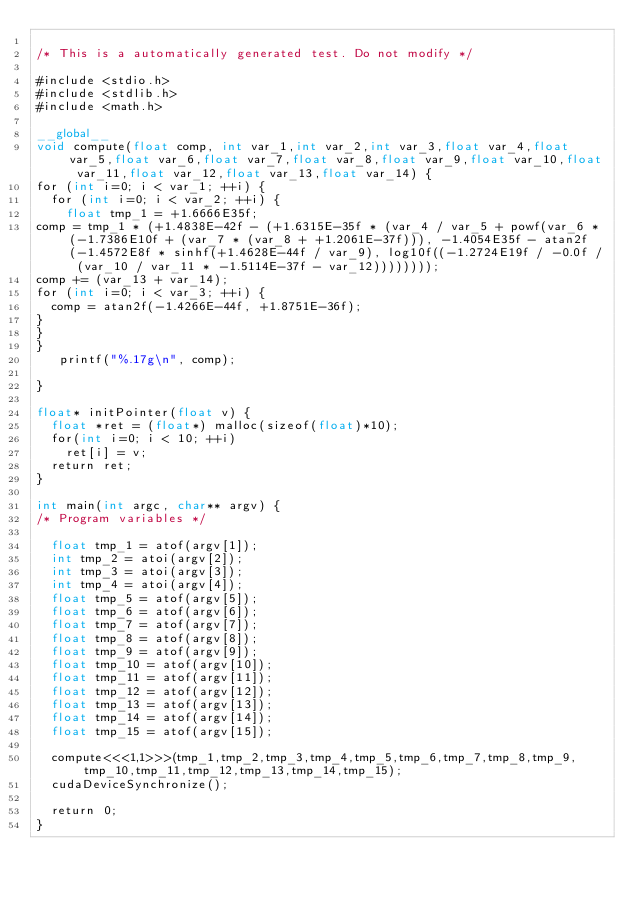<code> <loc_0><loc_0><loc_500><loc_500><_Cuda_>
/* This is a automatically generated test. Do not modify */

#include <stdio.h>
#include <stdlib.h>
#include <math.h>

__global__
void compute(float comp, int var_1,int var_2,int var_3,float var_4,float var_5,float var_6,float var_7,float var_8,float var_9,float var_10,float var_11,float var_12,float var_13,float var_14) {
for (int i=0; i < var_1; ++i) {
  for (int i=0; i < var_2; ++i) {
    float tmp_1 = +1.6666E35f;
comp = tmp_1 * (+1.4838E-42f - (+1.6315E-35f * (var_4 / var_5 + powf(var_6 * (-1.7386E10f + (var_7 * (var_8 + +1.2061E-37f))), -1.4054E35f - atan2f(-1.4572E8f * sinhf(+1.4628E-44f / var_9), log10f((-1.2724E19f / -0.0f / (var_10 / var_11 * -1.5114E-37f - var_12))))))));
comp += (var_13 + var_14);
for (int i=0; i < var_3; ++i) {
  comp = atan2f(-1.4266E-44f, +1.8751E-36f);
}
}
}
   printf("%.17g\n", comp);

}

float* initPointer(float v) {
  float *ret = (float*) malloc(sizeof(float)*10);
  for(int i=0; i < 10; ++i)
    ret[i] = v;
  return ret;
}

int main(int argc, char** argv) {
/* Program variables */

  float tmp_1 = atof(argv[1]);
  int tmp_2 = atoi(argv[2]);
  int tmp_3 = atoi(argv[3]);
  int tmp_4 = atoi(argv[4]);
  float tmp_5 = atof(argv[5]);
  float tmp_6 = atof(argv[6]);
  float tmp_7 = atof(argv[7]);
  float tmp_8 = atof(argv[8]);
  float tmp_9 = atof(argv[9]);
  float tmp_10 = atof(argv[10]);
  float tmp_11 = atof(argv[11]);
  float tmp_12 = atof(argv[12]);
  float tmp_13 = atof(argv[13]);
  float tmp_14 = atof(argv[14]);
  float tmp_15 = atof(argv[15]);

  compute<<<1,1>>>(tmp_1,tmp_2,tmp_3,tmp_4,tmp_5,tmp_6,tmp_7,tmp_8,tmp_9,tmp_10,tmp_11,tmp_12,tmp_13,tmp_14,tmp_15);
  cudaDeviceSynchronize();

  return 0;
}
</code> 